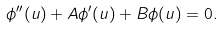<formula> <loc_0><loc_0><loc_500><loc_500>\phi ^ { \prime \prime } ( u ) + A \phi ^ { \prime } ( u ) + B \phi ( u ) = 0 .</formula> 